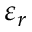Convert formula to latex. <formula><loc_0><loc_0><loc_500><loc_500>\varepsilon _ { r }</formula> 